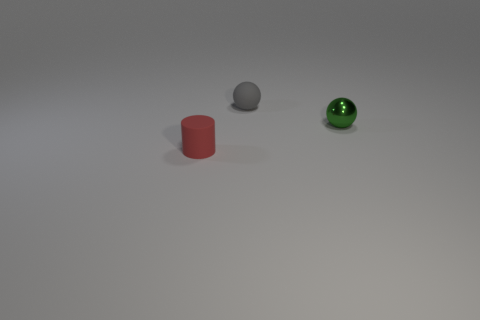Add 2 yellow balls. How many objects exist? 5 Subtract all spheres. How many objects are left? 1 Add 2 tiny blue things. How many tiny blue things exist? 2 Subtract 0 cyan blocks. How many objects are left? 3 Subtract all yellow things. Subtract all rubber objects. How many objects are left? 1 Add 3 green metal balls. How many green metal balls are left? 4 